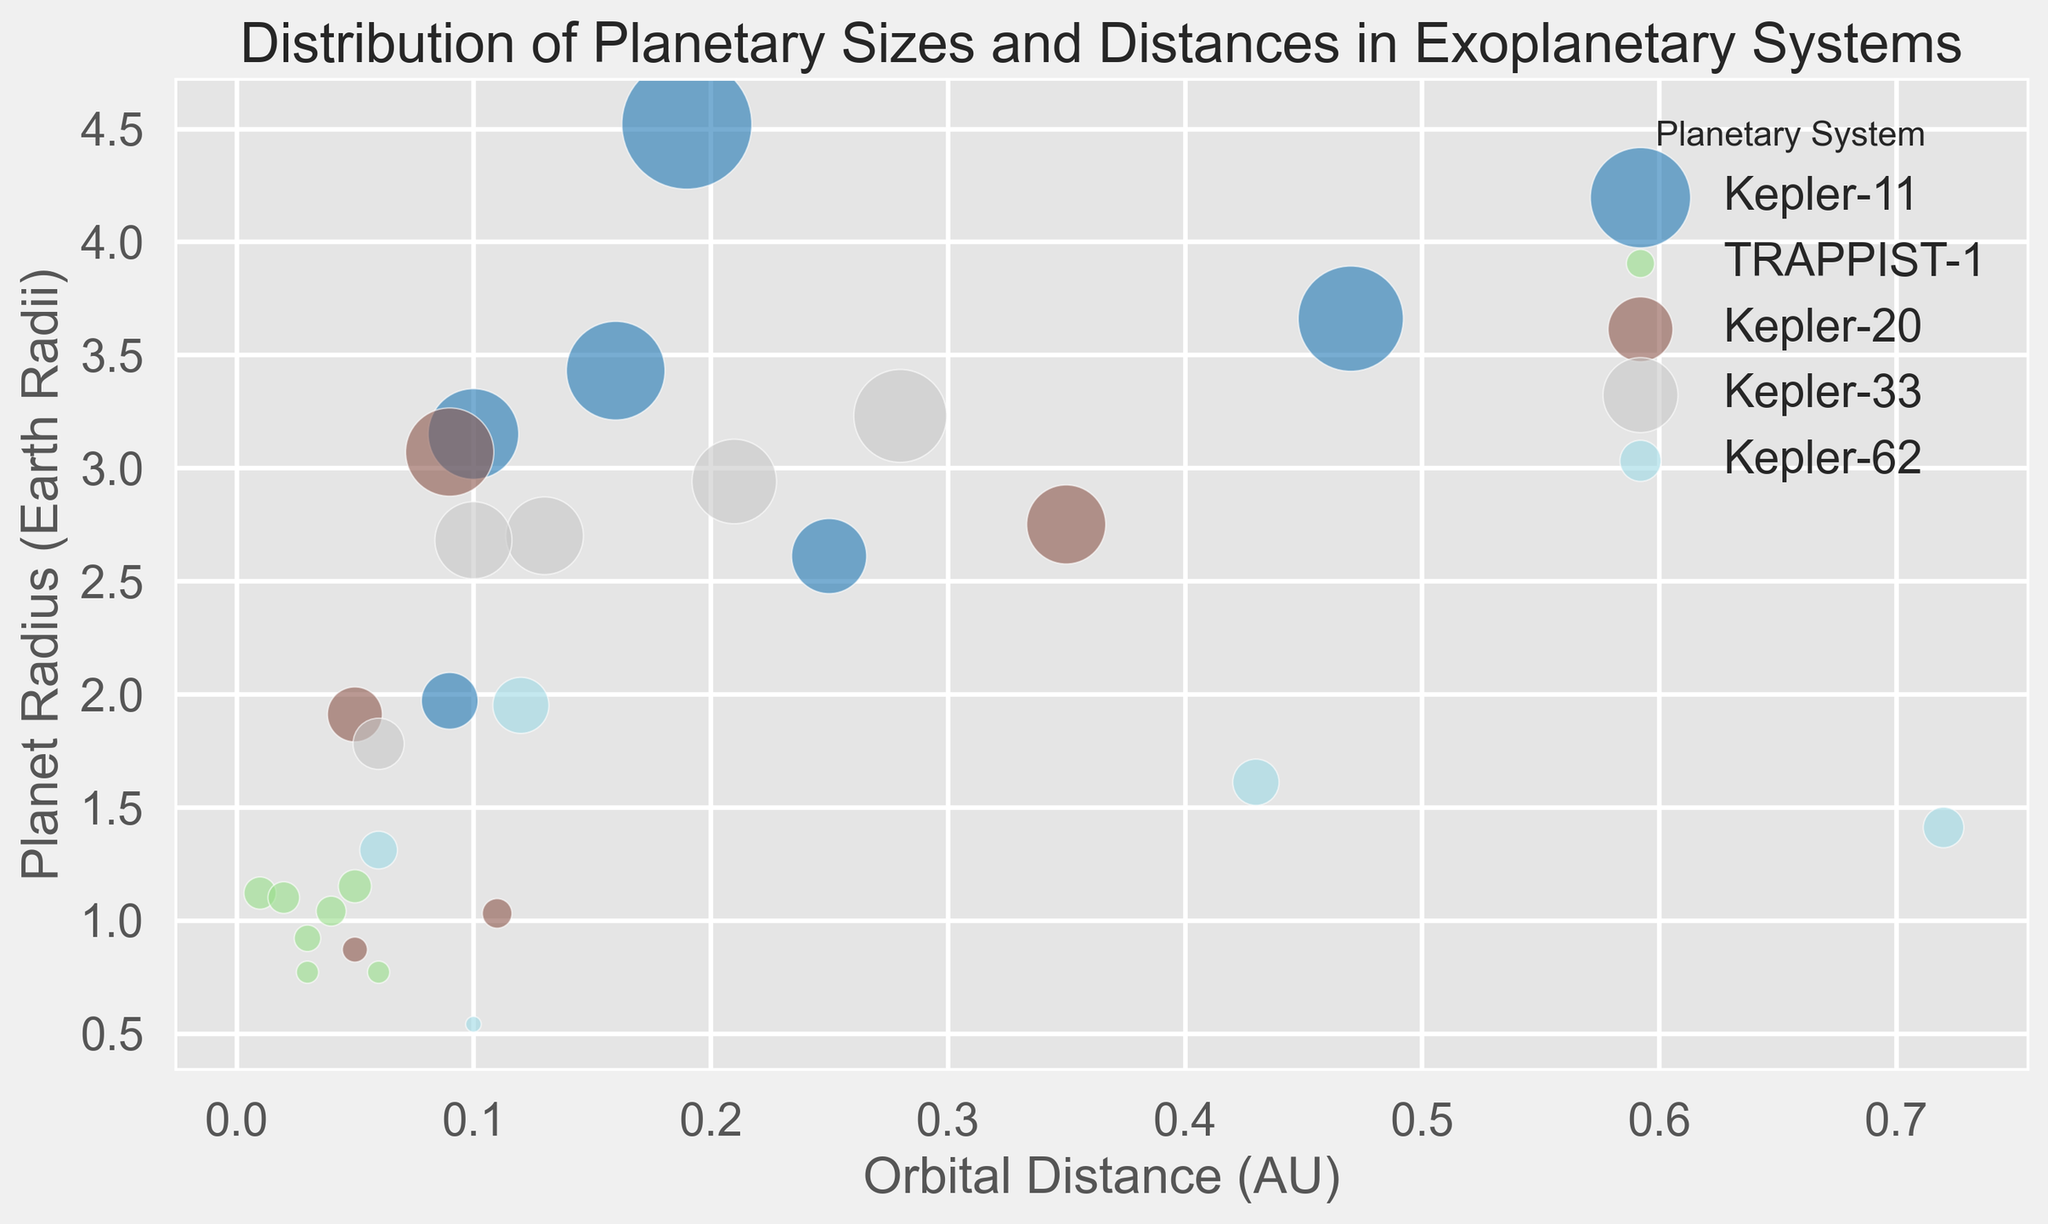What planetary system has the planet with the largest radius? Observing the bubble sizes in the chart, the largest bubble will represent the planet with the biggest radius. Thus, locating the biggest bubble and identifying its planetary system will provide the answer.
Answer: Kepler-11 Which planetary system has the planet that orbits the closest to its star? By examining the x-axis, which represents the orbital distance, the planet that appears furthest to the left has the smallest orbital distance. Identify its planetary system.
Answer: TRAPPIST-1 Compare the orbital distances of the planets in the TRAPPIST-1 system to those of the Kepler-11 system. Which system has planets closer to their star on average? Calculate the average orbital distance for planets in each planetary system. For TRAPPIST-1, sum the orbital distances and divide by the number of planets, and do the same for Kepler-11. Compare the averages.
Answer: TRAPPIST-1 Is there any planetary system in which all planets have an orbital distance greater than 0.1 AU? Review orbital distances for each planetary system. Identify a system where all planets are positioned to the right of the 0.1 AU mark on the x-axis.
Answer: No What is the radius range of planets within the Kepler-20 system? Examine the sizes of the bubbles for Kepler-20, and identify the smallest and largest bubble radii. Determine the range by subtracting the smallest from the largest.
Answer: 0.87 to 3.07 Earth Radii How does the orbital distance of Kepler-20b compare to Kepler-20e? Locate both planets on the plot and compare their positions along the x-axis.
Answer: Kepler-20b is further from its star than Kepler-20e For the Kepler-62 system, what is the planet with the largest radius, and what is its orbital distance? Look at the bubbles within the Kepler-62 system and locate the largest one. Read off the values for radius and orbital distance from the figure.
Answer: Kepler-62d, 0.12 AU Which system has more diversity in planetary sizes, Kepler-33 or Kepler-62? Compare the range of bubble sizes (planetary radii) for the planets within each system. Calculate the range by identifying the smallest and largest radii for each system and subtracting the smallest from the largest.
Answer: Kepler-33 